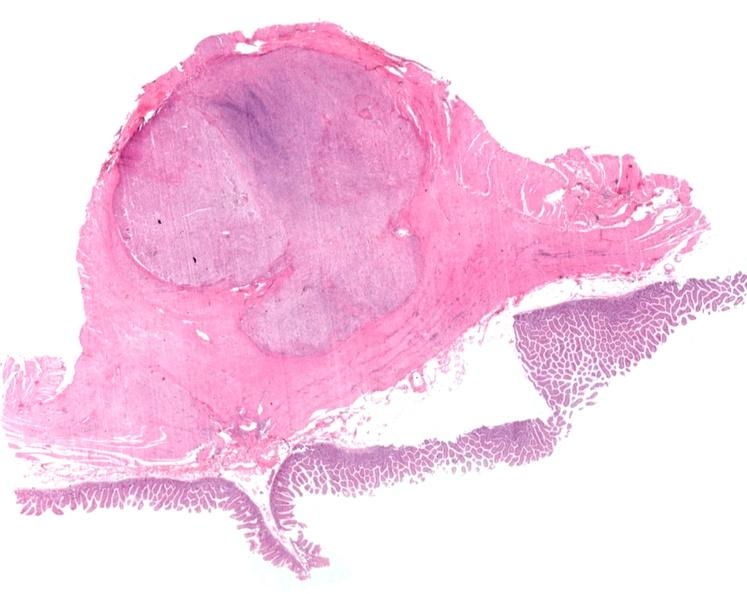where is this from?
Answer the question using a single word or phrase. Gastrointestinal system 